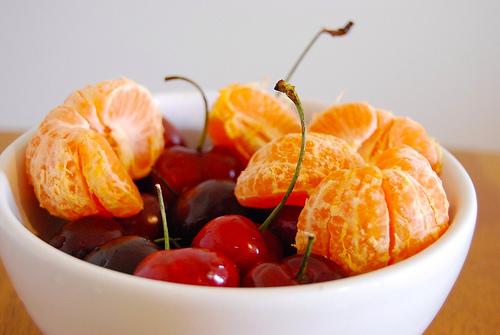What color is the fruit on the bottom?
Answer briefly. Red. Did Snow White bite into one of these?
Short answer required. No. What types of fruit are in the bowl?
Be succinct. Oranges and cherries. Where are the cherries?
Quick response, please. In bowl. What kind of fruit is in the bowl?
Short answer required. Cherries and oranges. Is this breakfast cereal?
Quick response, please. No. 